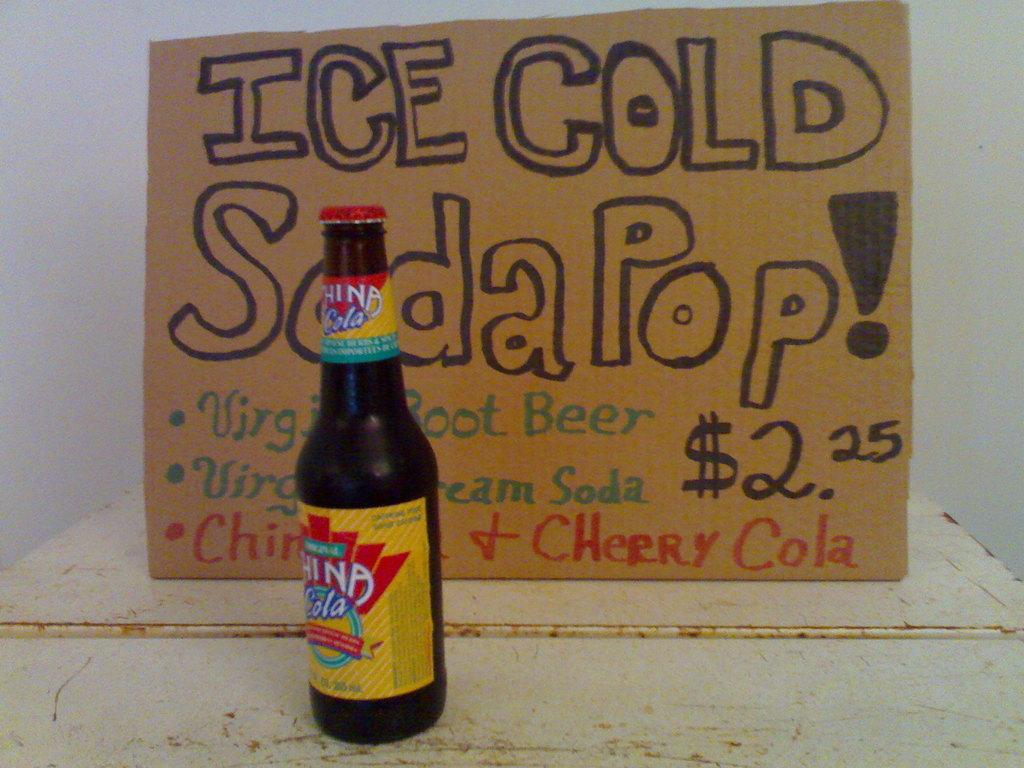<image>
Provide a brief description of the given image. An artistic hand written sign saying Ice Cold Soda Pop  with a pop bottle next to it. 